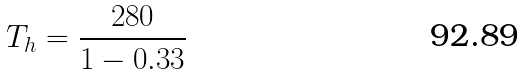Convert formula to latex. <formula><loc_0><loc_0><loc_500><loc_500>T _ { h } = \frac { 2 8 0 } { 1 - 0 . 3 3 }</formula> 